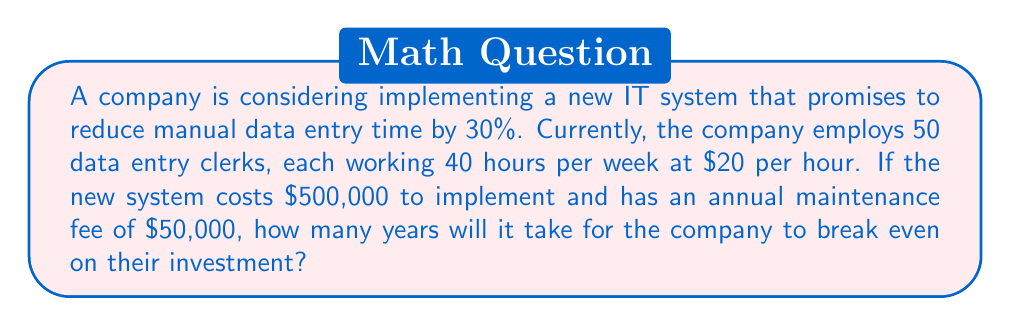Teach me how to tackle this problem. Let's approach this problem step-by-step:

1. Calculate the current annual cost of data entry:
   $$ \text{Annual cost} = 50 \text{ clerks} \times 40 \text{ hours/week} \times 52 \text{ weeks} \times \$20/\text{hour} = \$2,080,000 $$

2. Calculate the annual savings from the new system:
   $$ \text{Annual savings} = 30\% \times \$2,080,000 = \$624,000 $$

3. Calculate the annual cost of the new system:
   $$ \text{Annual cost of new system} = \$50,000 \text{ (maintenance fee)} $$

4. Calculate the net annual savings:
   $$ \text{Net annual savings} = \$624,000 - \$50,000 = \$574,000 $$

5. Calculate the break-even time:
   Let $x$ be the number of years to break even.
   $$ 500,000 + 50,000x = 574,000x $$
   $$ 500,000 = 524,000x $$
   $$ x = \frac{500,000}{524,000} \approx 0.954 \text{ years} $$

6. Convert to years and months:
   $$ 0.954 \text{ years} = 11.45 \text{ months} \approx 11 \text{ months and 14 days} $$
Answer: 11 months and 14 days 